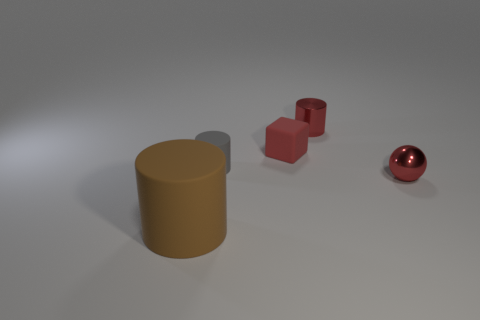There is a rubber cylinder that is on the right side of the rubber thing left of the gray object; what is its color? The rubber cylinder to the right of the object on the left and in front of the gray object appears to have a mustard yellow color. This hue is distinct from the red and silver-toned objects in the image, providing a clear contrast. 